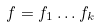Convert formula to latex. <formula><loc_0><loc_0><loc_500><loc_500>f = f _ { 1 } \dots f _ { k }</formula> 